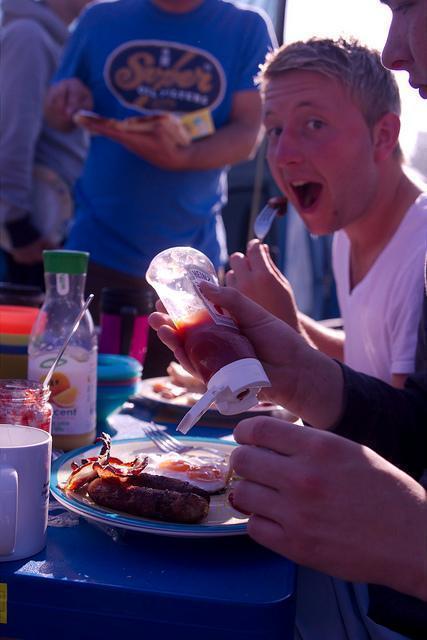Why are the men seated?
Pick the correct solution from the four options below to address the question.
Options: To eat, play chess, draw, to work. To eat. 